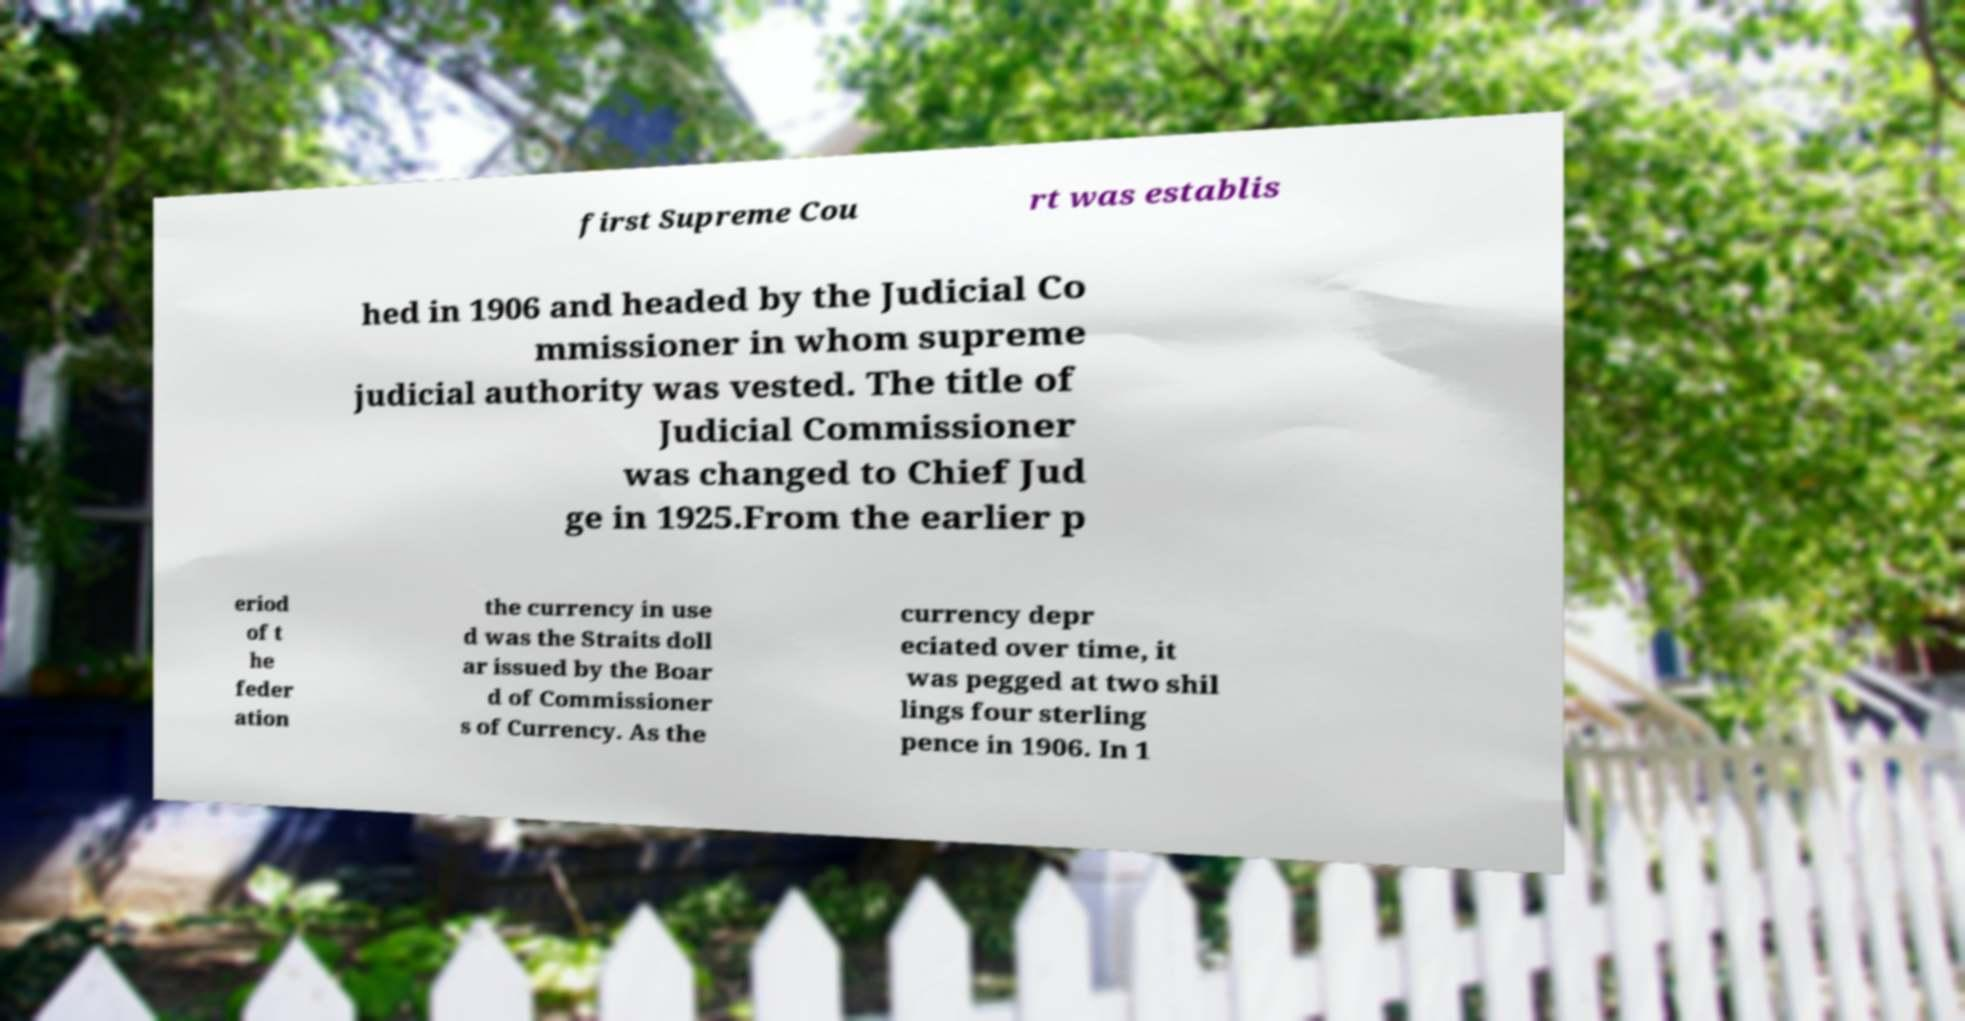There's text embedded in this image that I need extracted. Can you transcribe it verbatim? first Supreme Cou rt was establis hed in 1906 and headed by the Judicial Co mmissioner in whom supreme judicial authority was vested. The title of Judicial Commissioner was changed to Chief Jud ge in 1925.From the earlier p eriod of t he feder ation the currency in use d was the Straits doll ar issued by the Boar d of Commissioner s of Currency. As the currency depr eciated over time, it was pegged at two shil lings four sterling pence in 1906. In 1 